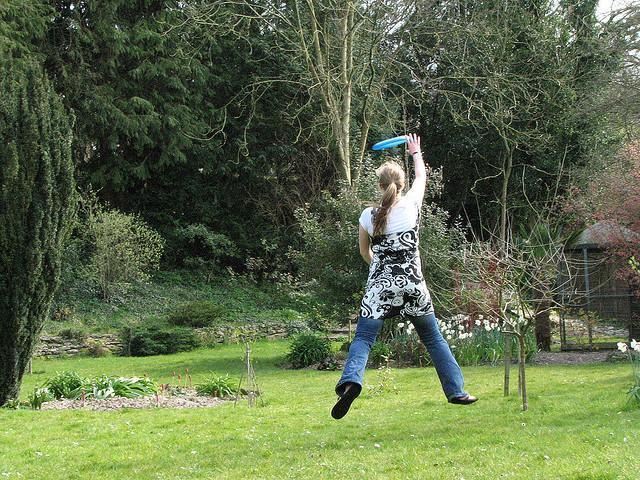How many people are driving a motorcycle in this image?
Give a very brief answer. 0. 